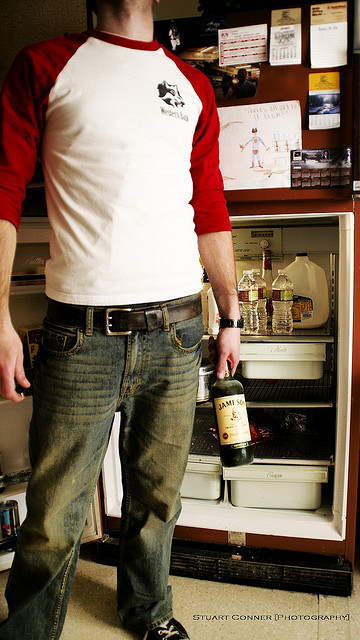Identify the text displayed in this image. PHOTOGRAPHY CONNER STUART 